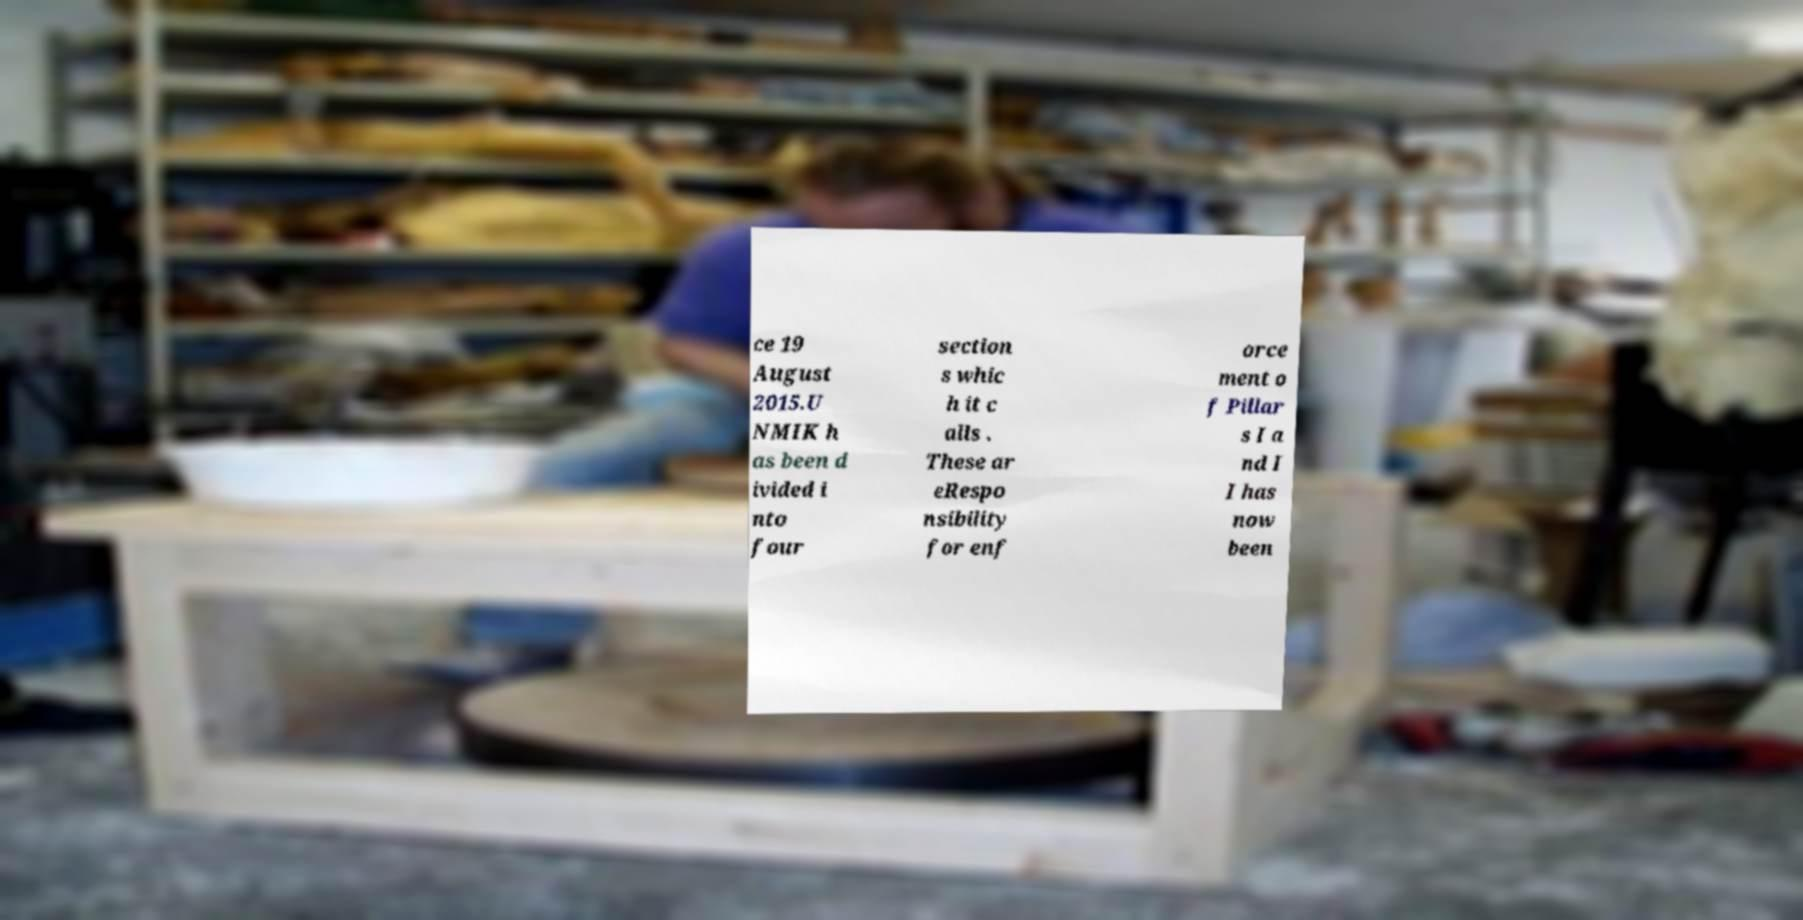I need the written content from this picture converted into text. Can you do that? ce 19 August 2015.U NMIK h as been d ivided i nto four section s whic h it c alls . These ar eRespo nsibility for enf orce ment o f Pillar s I a nd I I has now been 